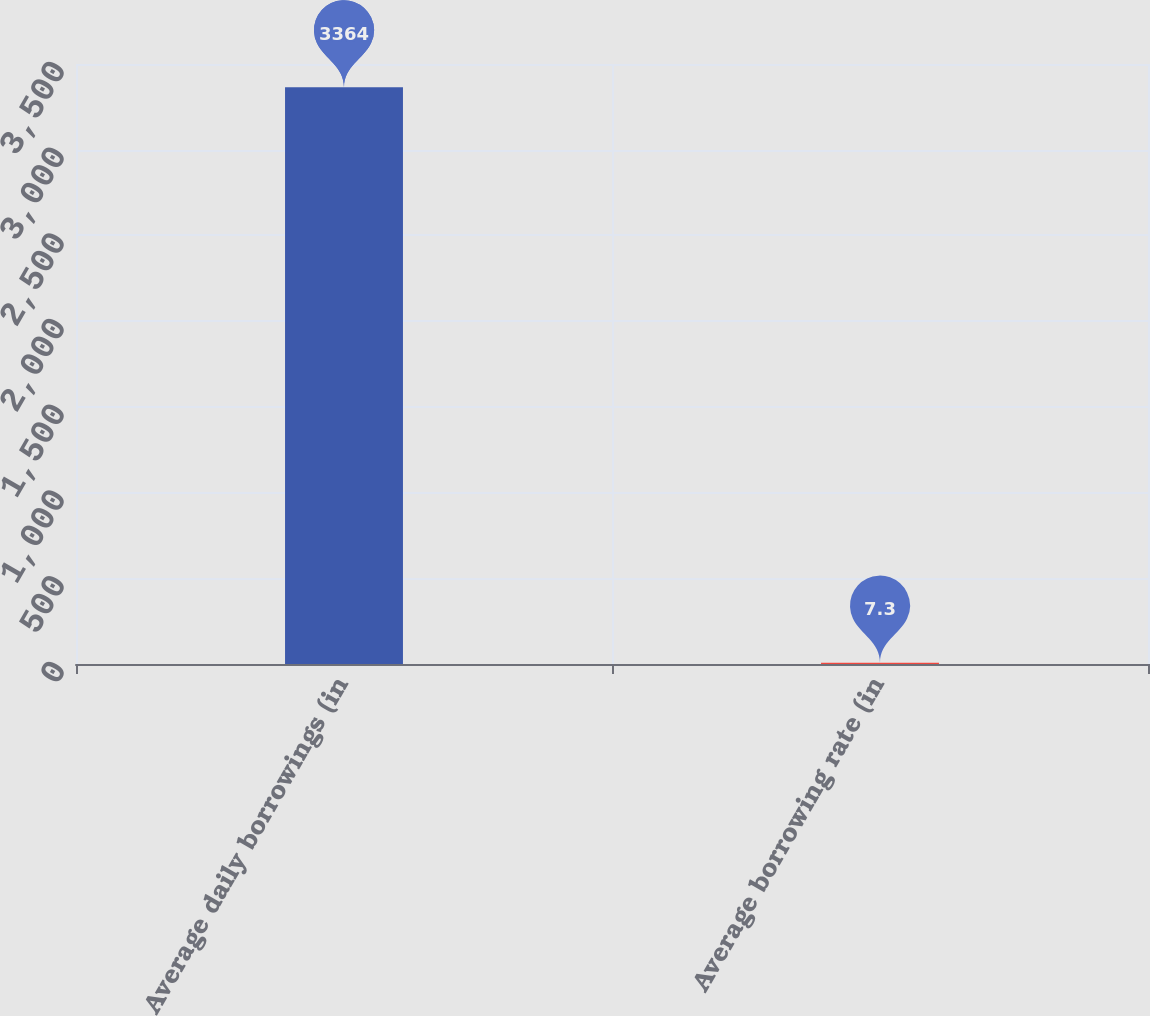Convert chart. <chart><loc_0><loc_0><loc_500><loc_500><bar_chart><fcel>Average daily borrowings (in<fcel>Average borrowing rate (in<nl><fcel>3364<fcel>7.3<nl></chart> 